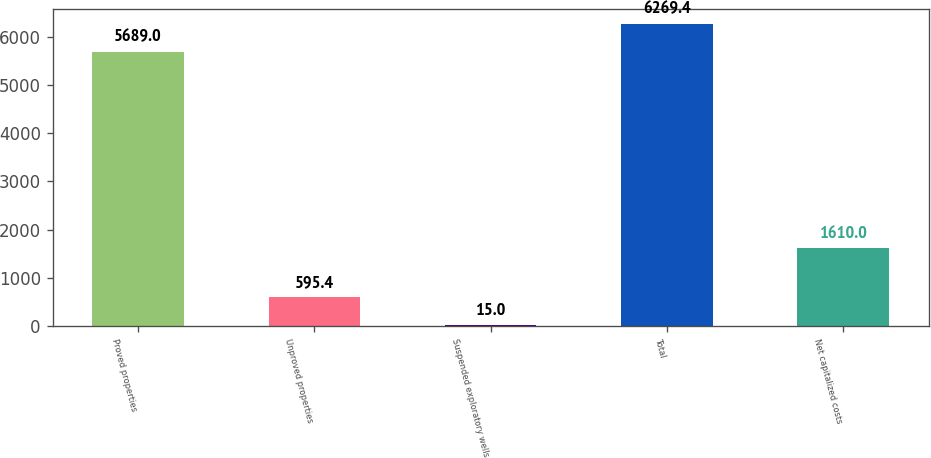Convert chart to OTSL. <chart><loc_0><loc_0><loc_500><loc_500><bar_chart><fcel>Proved properties<fcel>Unproved properties<fcel>Suspended exploratory wells<fcel>Total<fcel>Net capitalized costs<nl><fcel>5689<fcel>595.4<fcel>15<fcel>6269.4<fcel>1610<nl></chart> 